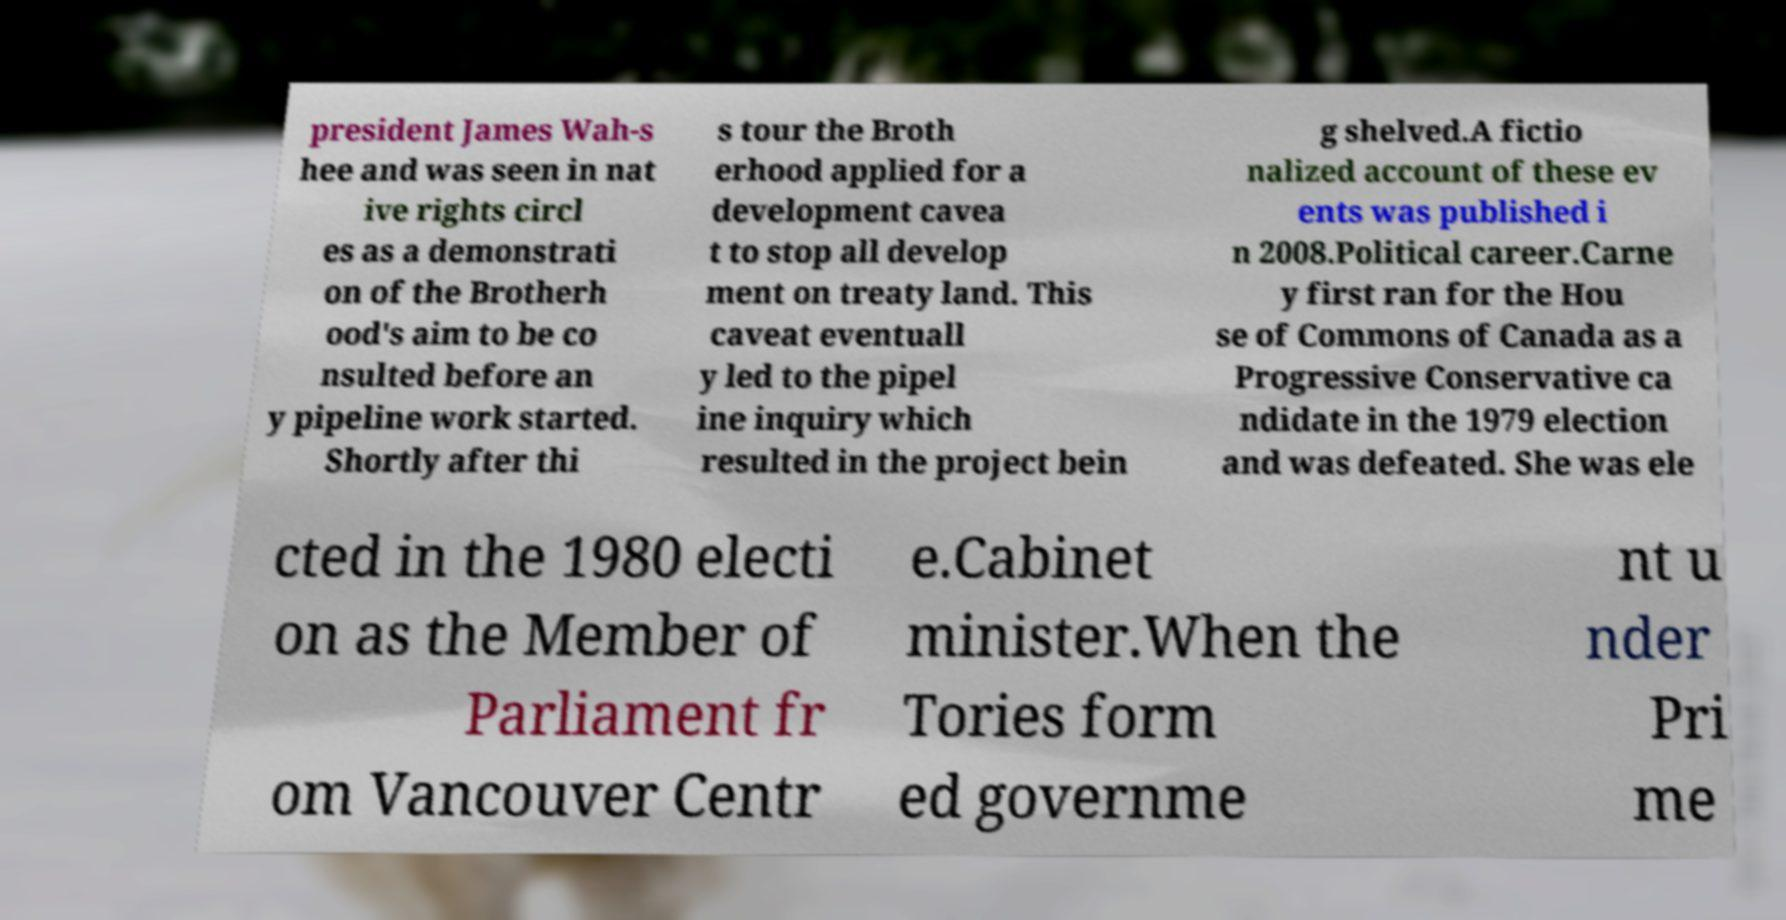There's text embedded in this image that I need extracted. Can you transcribe it verbatim? president James Wah-s hee and was seen in nat ive rights circl es as a demonstrati on of the Brotherh ood's aim to be co nsulted before an y pipeline work started. Shortly after thi s tour the Broth erhood applied for a development cavea t to stop all develop ment on treaty land. This caveat eventuall y led to the pipel ine inquiry which resulted in the project bein g shelved.A fictio nalized account of these ev ents was published i n 2008.Political career.Carne y first ran for the Hou se of Commons of Canada as a Progressive Conservative ca ndidate in the 1979 election and was defeated. She was ele cted in the 1980 electi on as the Member of Parliament fr om Vancouver Centr e.Cabinet minister.When the Tories form ed governme nt u nder Pri me 